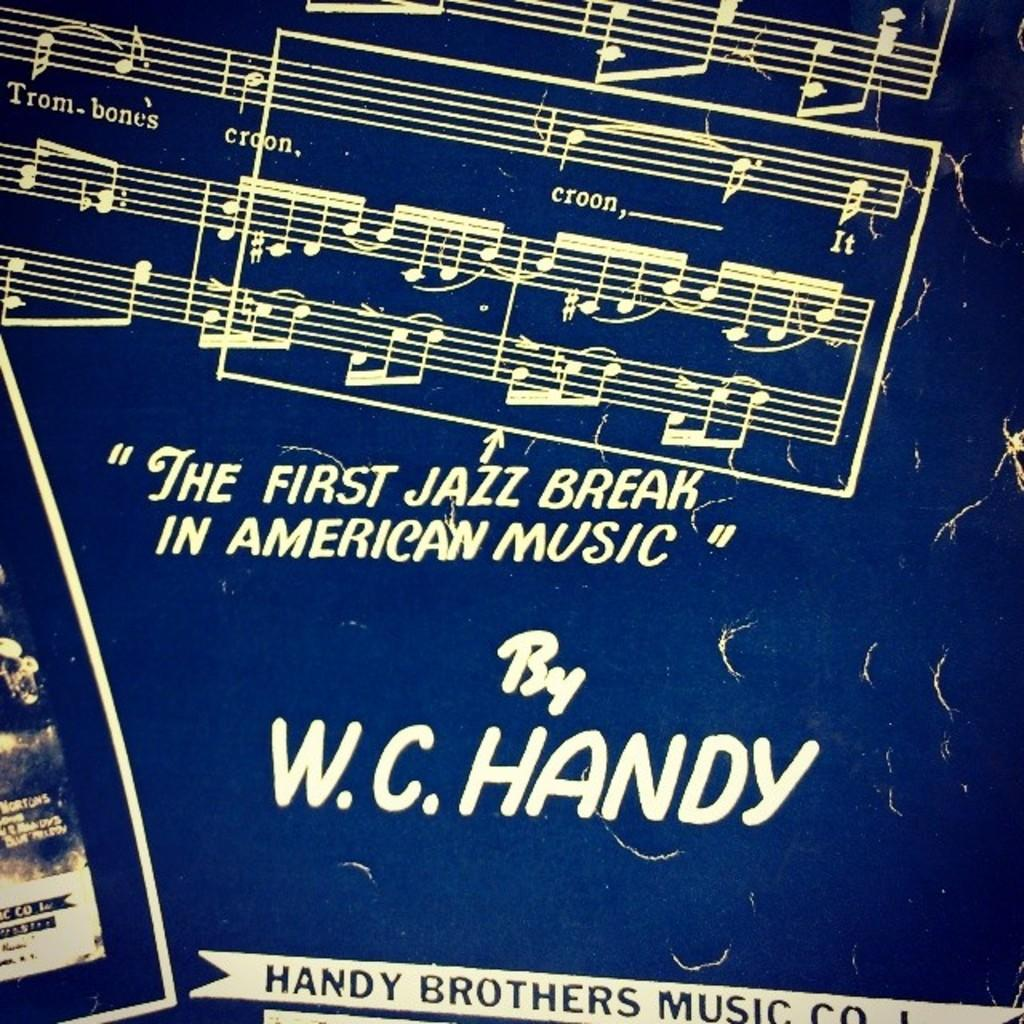<image>
Render a clear and concise summary of the photo. A blue covered music book written by W.C. Handy. 